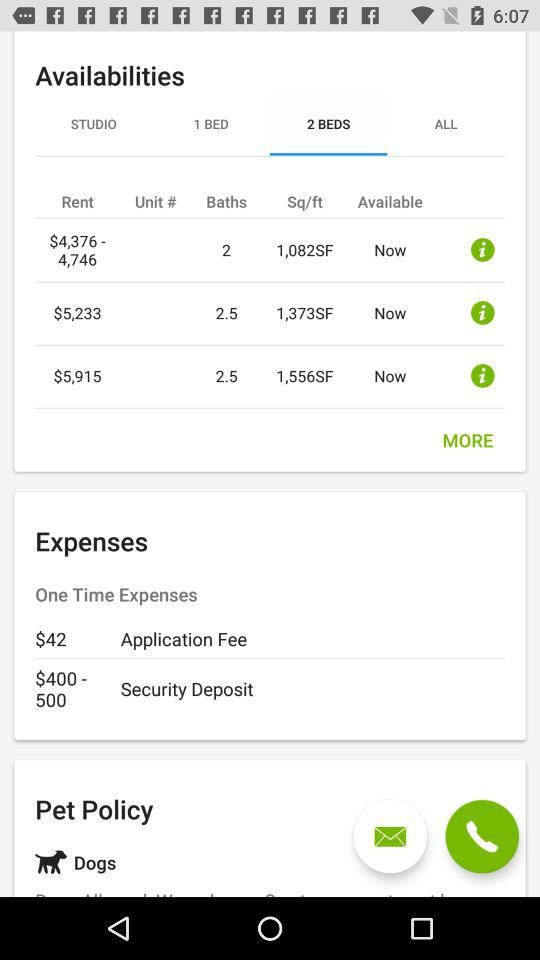What pet is mentioned? The pet mentioned is a dog. 